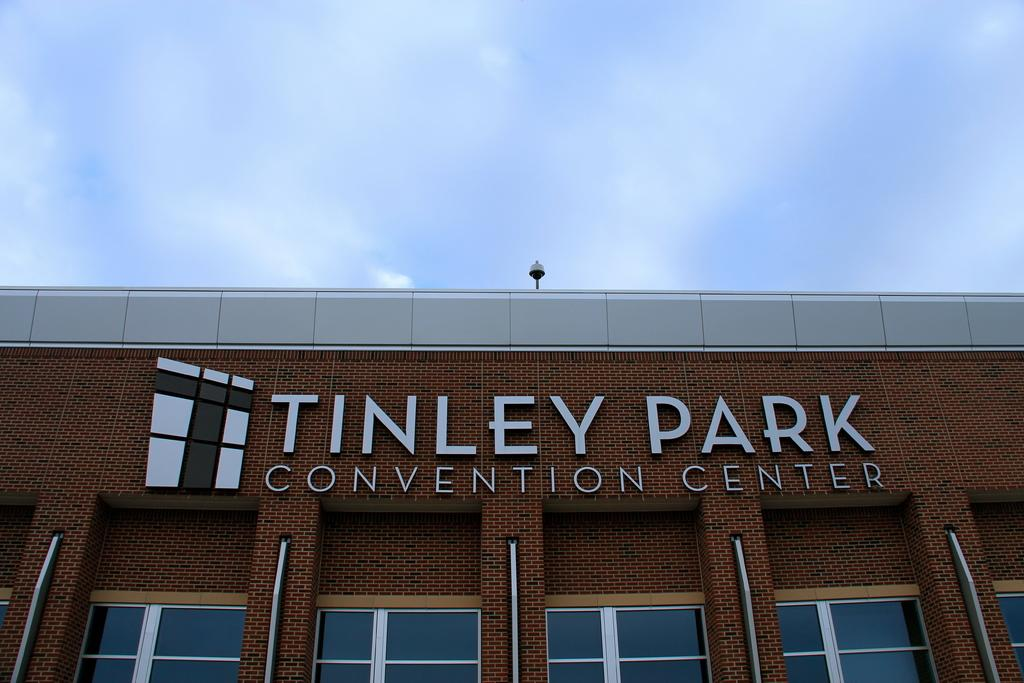What type of structure is in the image? There is a building in the image. What feature can be seen on the building? There are windows visible on the building. What is the purpose of the object near the building? A street light is present in the image. What can be seen in the background of the image? The sky is visible in the image. What is the condition of the sky in the image? Clouds are present in the sky. What type of liquid can be seen flowing from the building in the image? There is no liquid flowing from the building in the image. Are there any slaves depicted in the image? There are no slaves depicted in the image. 